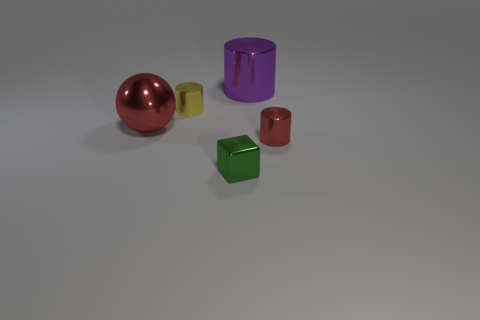There is a tiny thing that is the same color as the metal sphere; what shape is it?
Provide a short and direct response. Cylinder. Are there fewer small metallic things behind the big purple metal cylinder than tiny red things to the right of the small red object?
Give a very brief answer. No. There is a thing that is both left of the green cube and in front of the tiny yellow thing; what is its material?
Provide a short and direct response. Metal. Do the green thing and the red shiny object that is on the left side of the tiny green thing have the same shape?
Offer a very short reply. No. How many other objects are the same size as the metallic ball?
Provide a succinct answer. 1. Is the number of big purple metallic objects greater than the number of rubber things?
Give a very brief answer. Yes. How many cylinders are both on the right side of the tiny metallic block and on the left side of the tiny green block?
Your answer should be very brief. 0. What shape is the big metal object that is to the left of the small thing that is in front of the cylinder to the right of the purple metal cylinder?
Ensure brevity in your answer.  Sphere. Are there any other things that are the same shape as the small yellow thing?
Offer a terse response. Yes. What number of spheres are either tiny cyan metal things or green things?
Your answer should be very brief. 0. 